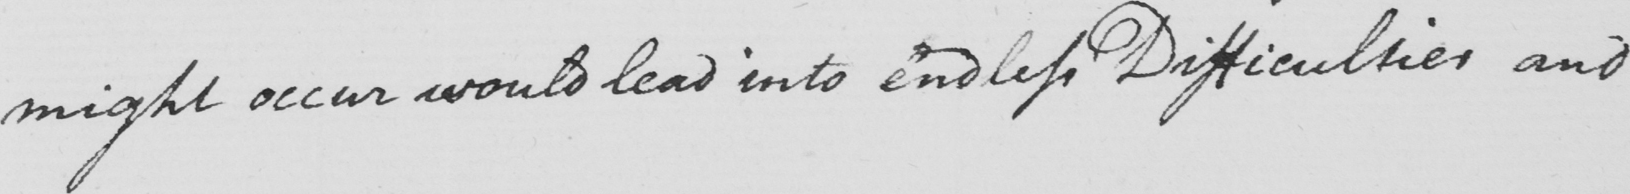Can you tell me what this handwritten text says? might occur would lead into endless Difficulties and 